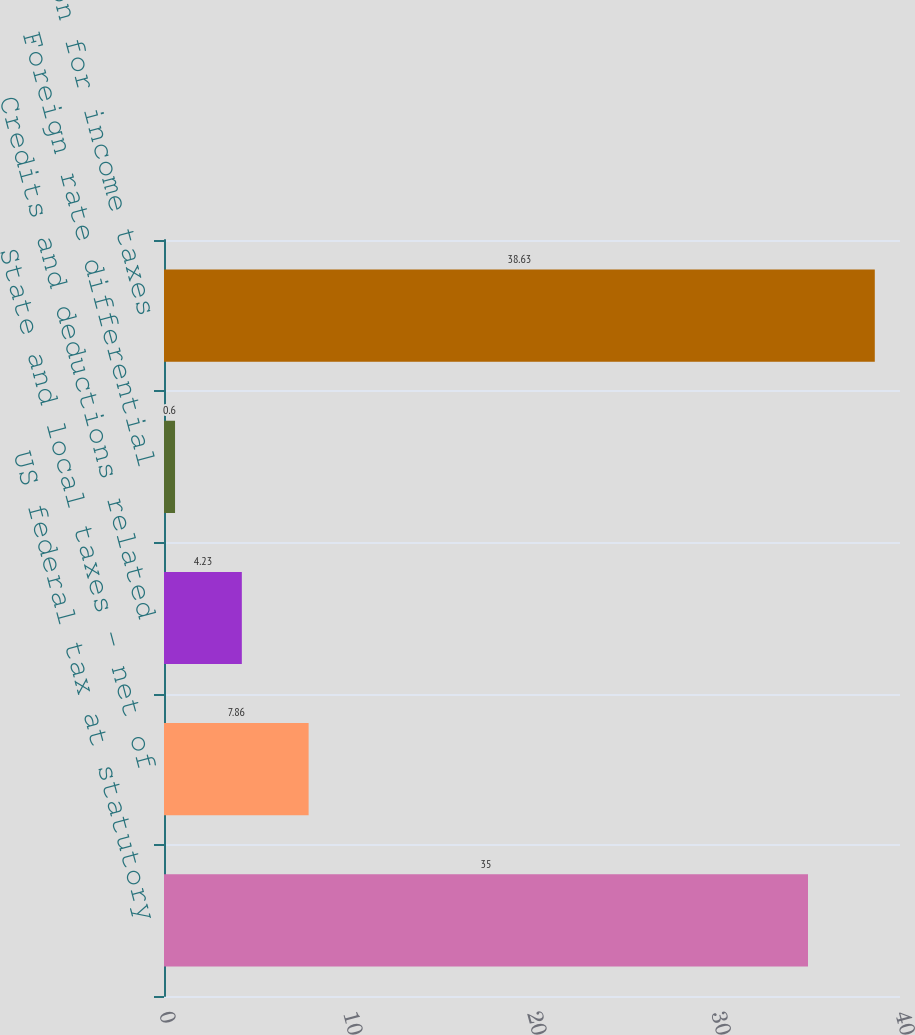Convert chart. <chart><loc_0><loc_0><loc_500><loc_500><bar_chart><fcel>US federal tax at statutory<fcel>State and local taxes - net of<fcel>Credits and deductions related<fcel>Foreign rate differential<fcel>Provision for income taxes<nl><fcel>35<fcel>7.86<fcel>4.23<fcel>0.6<fcel>38.63<nl></chart> 